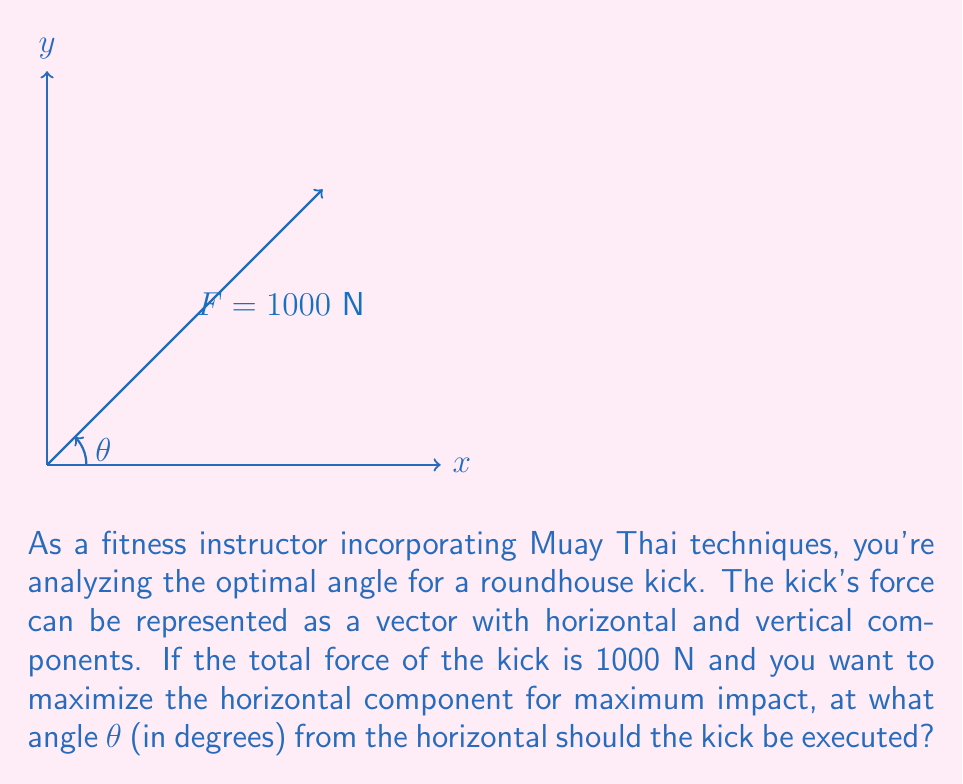What is the answer to this math problem? Let's approach this step-by-step:

1) The force vector F can be decomposed into horizontal (x) and vertical (y) components:
   $$F_x = F \cos(\theta)$$
   $$F_y = F \sin(\theta)$$

2) We want to maximize the horizontal component $F_x$. In vector calculus, this occurs when the derivative of $F_x$ with respect to θ is zero:

   $$\frac{d}{d\theta}(F \cos(\theta)) = -F \sin(\theta) = 0$$

3) This equation is satisfied when $\sin(\theta) = 0$, which occurs at $\theta = 0°$ or $180°$. However, $0°$ is not practical for a kick, and $180°$ would be kicking backwards.

4) The next best angle is when $\cos(\theta)$ is at its maximum positive value, which occurs at $45°$. This angle provides the optimal balance between horizontal force and practicality of execution.

5) At $45°$, both $\cos(\theta)$ and $\sin(\theta)$ equal $\frac{1}{\sqrt{2}} \approx 0.707$

6) Therefore, at this angle:
   $$F_x = F_y = 1000 \cdot \frac{1}{\sqrt{2}} \approx 707.1 \text{ N}$$

This angle provides the maximum horizontal force while still maintaining a significant vertical component, which is crucial for the roundhouse kick's effectiveness and balance.
Answer: $45°$ 